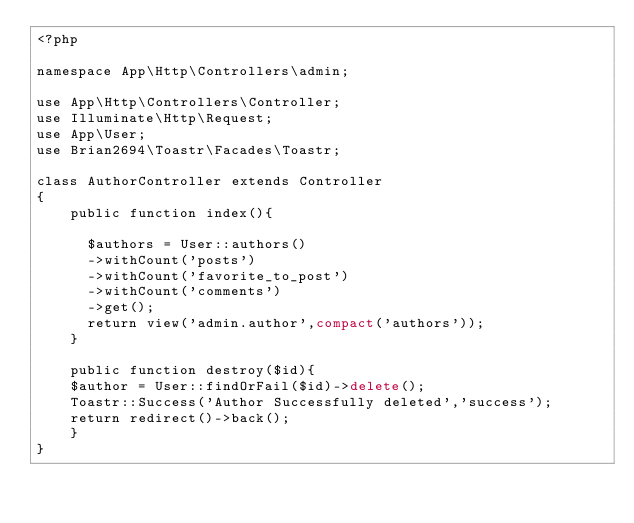Convert code to text. <code><loc_0><loc_0><loc_500><loc_500><_PHP_><?php

namespace App\Http\Controllers\admin;

use App\Http\Controllers\Controller;
use Illuminate\Http\Request;
use App\User;
use Brian2694\Toastr\Facades\Toastr;

class AuthorController extends Controller
{
    public function index(){

      $authors = User::authors()
      ->withCount('posts')
      ->withCount('favorite_to_post')
      ->withCount('comments')
      ->get();
      return view('admin.author',compact('authors'));
    }

    public function destroy($id){
    $author = User::findOrFail($id)->delete();
    Toastr::Success('Author Successfully deleted','success');
    return redirect()->back();
    }
}
</code> 